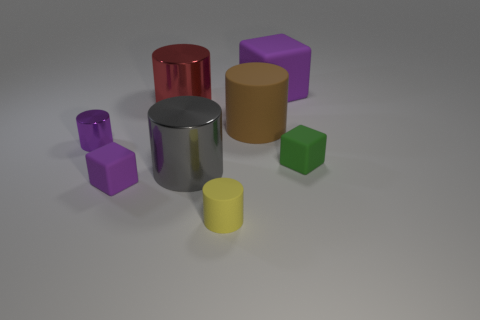Subtract all red cylinders. How many cylinders are left? 4 Subtract all brown cylinders. How many purple cubes are left? 2 Subtract all purple cylinders. How many cylinders are left? 4 Subtract 3 cylinders. How many cylinders are left? 2 Add 1 yellow cylinders. How many objects exist? 9 Subtract all yellow cylinders. Subtract all brown balls. How many cylinders are left? 4 Subtract all cylinders. How many objects are left? 3 Add 7 purple cylinders. How many purple cylinders are left? 8 Add 2 brown matte cylinders. How many brown matte cylinders exist? 3 Subtract 0 blue balls. How many objects are left? 8 